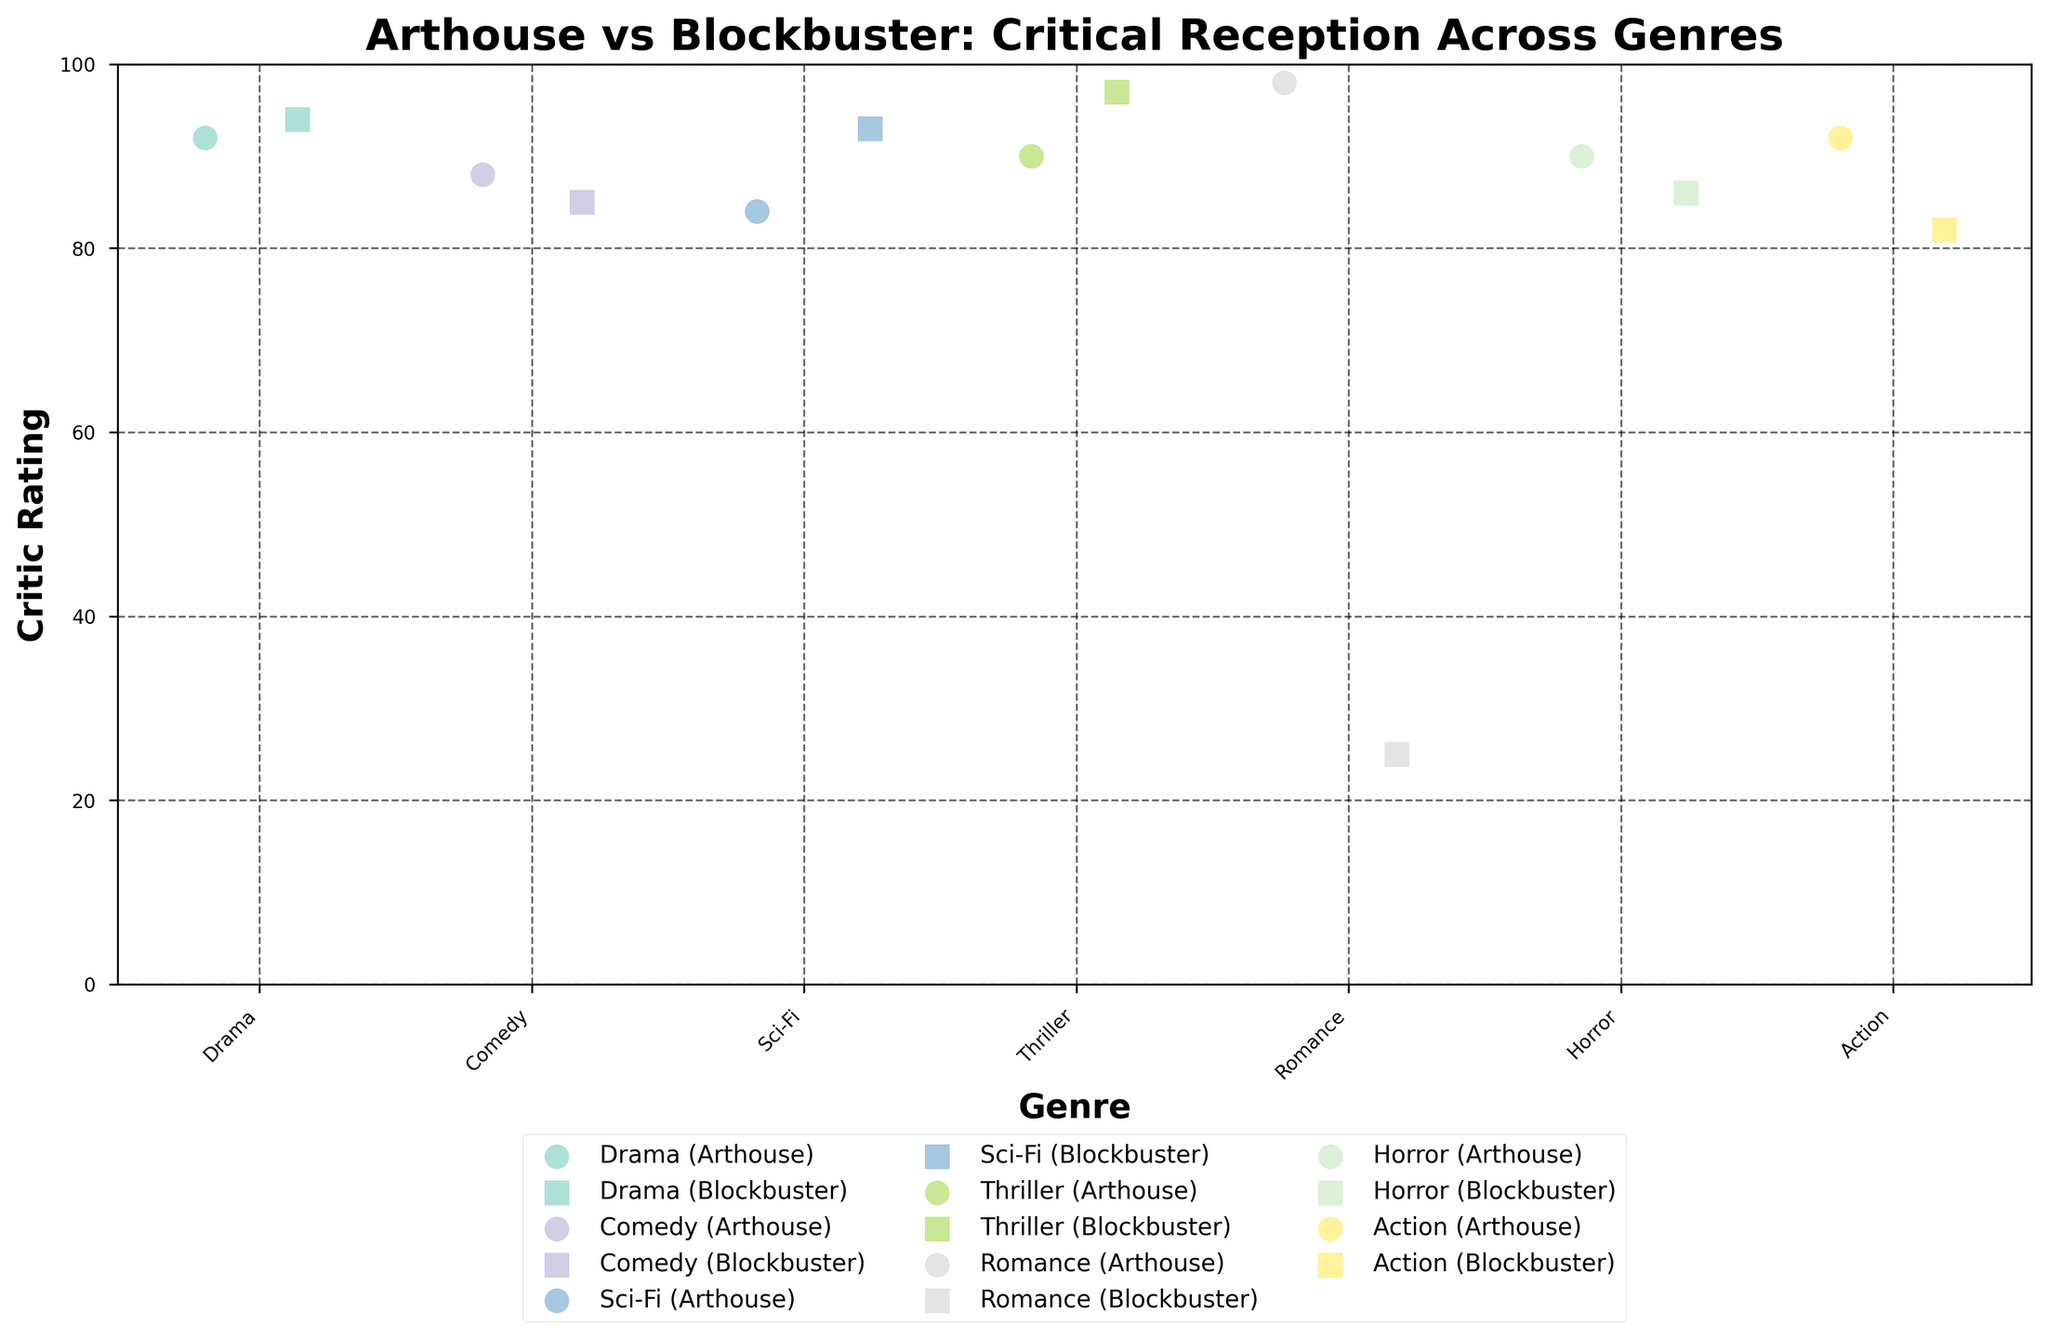What is the title of the figure? The title of the figure is usually found at the top of the plot. It provides a brief description of what the figure represents. In this case, the title is "Arthouse vs Blockbuster: Critical Reception Across Genres".
Answer: Arthouse vs Blockbuster: Critical Reception Across Genres How many genres are displayed in the figure? To find the number of genres, count the unique categories along the x-axis. Here, the unique genres are Drama, Comedy, Sci-Fi, Thriller, Romance, Horror, and Action.
Answer: 7 Which genre has the highest critic rating for a blockbuster film? Locate the highest points for blockbuster films (square markers) across different genres. The Thriller genre has the highest rating for a blockbuster with "Mission: Impossible - Fallout" scoring 97.
Answer: Thriller What is the lowest critic rating for a blockbuster film? Find the lowest point for the square markers, which represent blockbuster films. The lowest rating is in the Romance genre with "Fifty Shades of Grey" scoring 25.
Answer: 25 Which Arthouse film has the highest critic rating? Identify the highest point among the circular markers that represent arthouse films. The highest rating is 98, which corresponds to "Portrait of a Lady on Fire" in the Romance genre.
Answer: Portrait of a Lady on Fire What are the critic ratings of Drama films? Look at the points within the Drama genre category. The ratings are: "The Father" (Arthouse) has 92 and "Avengers: Endgame" (Blockbuster) has 94.
Answer: 92 and 94 How do the average critic ratings of Arthouse and Blockbuster films compare? Calculate the average rating for all arthouse films and all blockbuster films. Arthouse: (92+88+84+90+98+90+92)/7 = 90.57. Blockbuster: (94+85+93+97+25+86+82)/7 = 80.29. Compare these two averages.
Answer: Arthouse: 90.57, Blockbuster: 80.29 In which genre are arthouse and blockbuster films most equally rated? Compare the critic ratings within each genre to find the smallest difference. The minimal difference is for Drama, with "The Father" at 92 and "Avengers: Endgame" at 94, a difference of 2.
Answer: Drama What is the range of critic ratings for Comedy films? Find the highest and lowest ratings for Comedy films. The Lobster (Arthouse) has 88 and Deadpool (Blockbuster) has 85. The range is 88 - 85 = 3.
Answer: 3 